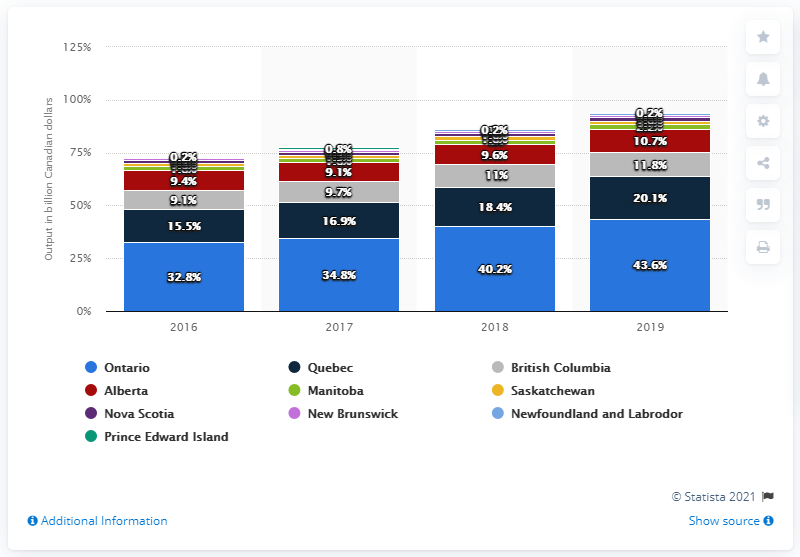List a handful of essential elements in this visual. In 2019, the ICT sector output in Ontario was $43.6 billion. Quebec is the second largest Information and Communications Technology (ICT) province in Ontario. 